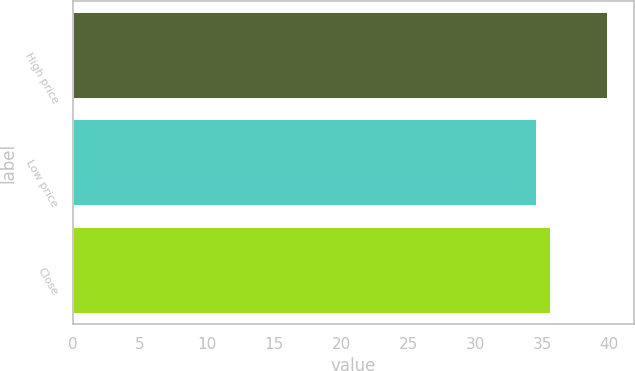Convert chart. <chart><loc_0><loc_0><loc_500><loc_500><bar_chart><fcel>High price<fcel>Low price<fcel>Close<nl><fcel>39.82<fcel>34.54<fcel>35.58<nl></chart> 